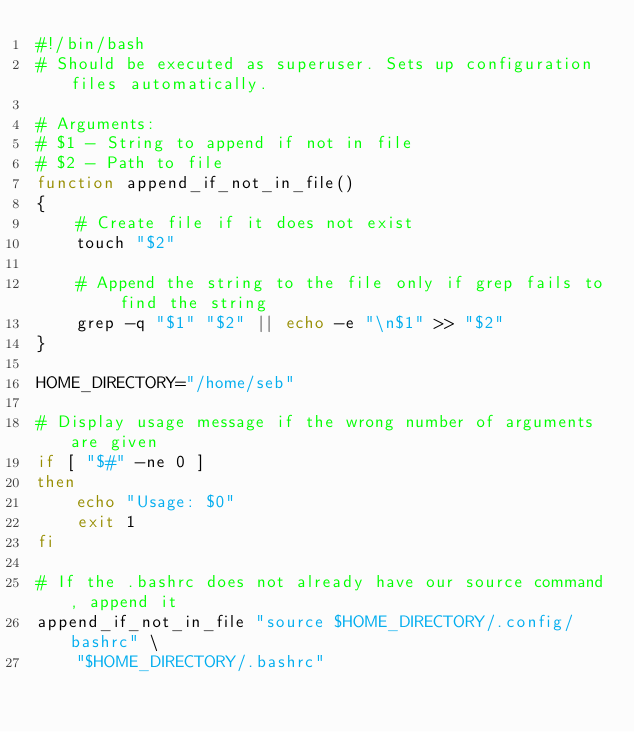<code> <loc_0><loc_0><loc_500><loc_500><_Bash_>#!/bin/bash
# Should be executed as superuser. Sets up configuration files automatically.

# Arguments:
# $1 - String to append if not in file
# $2 - Path to file
function append_if_not_in_file() 
{
	# Create file if it does not exist
	touch "$2"

	# Append the string to the file only if grep fails to find the string
	grep -q "$1" "$2" || echo -e "\n$1" >> "$2"
}

HOME_DIRECTORY="/home/seb"

# Display usage message if the wrong number of arguments are given
if [ "$#" -ne 0 ]
then
	echo "Usage: $0"
	exit 1
fi

# If the .bashrc does not already have our source command, append it
append_if_not_in_file "source $HOME_DIRECTORY/.config/bashrc" \
	"$HOME_DIRECTORY/.bashrc"
</code> 